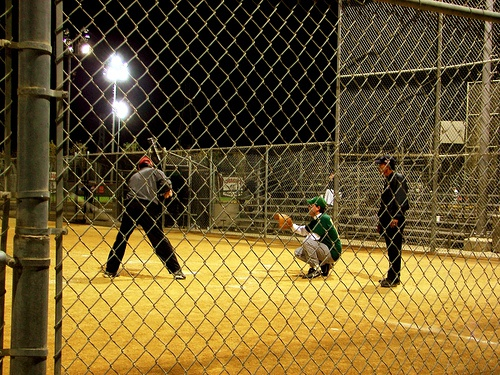Describe the objects in this image and their specific colors. I can see people in black, olive, maroon, and gray tones, people in black, maroon, and olive tones, people in black, olive, tan, and maroon tones, people in black, ivory, olive, and gray tones, and baseball glove in black, brown, olive, and maroon tones in this image. 